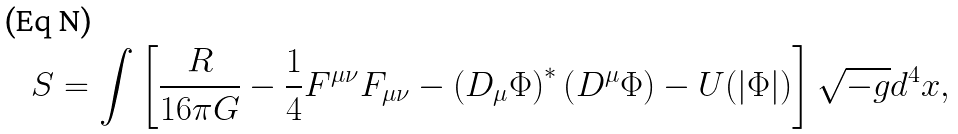Convert formula to latex. <formula><loc_0><loc_0><loc_500><loc_500>S = \int \left [ \frac { R } { 1 6 \pi G } - \frac { 1 } { 4 } F ^ { \mu \nu } F _ { \mu \nu } - \left ( D _ { \mu } \Phi \right ) ^ { * } \left ( D ^ { \mu } \Phi \right ) - U ( \left | \Phi \right | ) \right ] \sqrt { - g } d ^ { 4 } x ,</formula> 